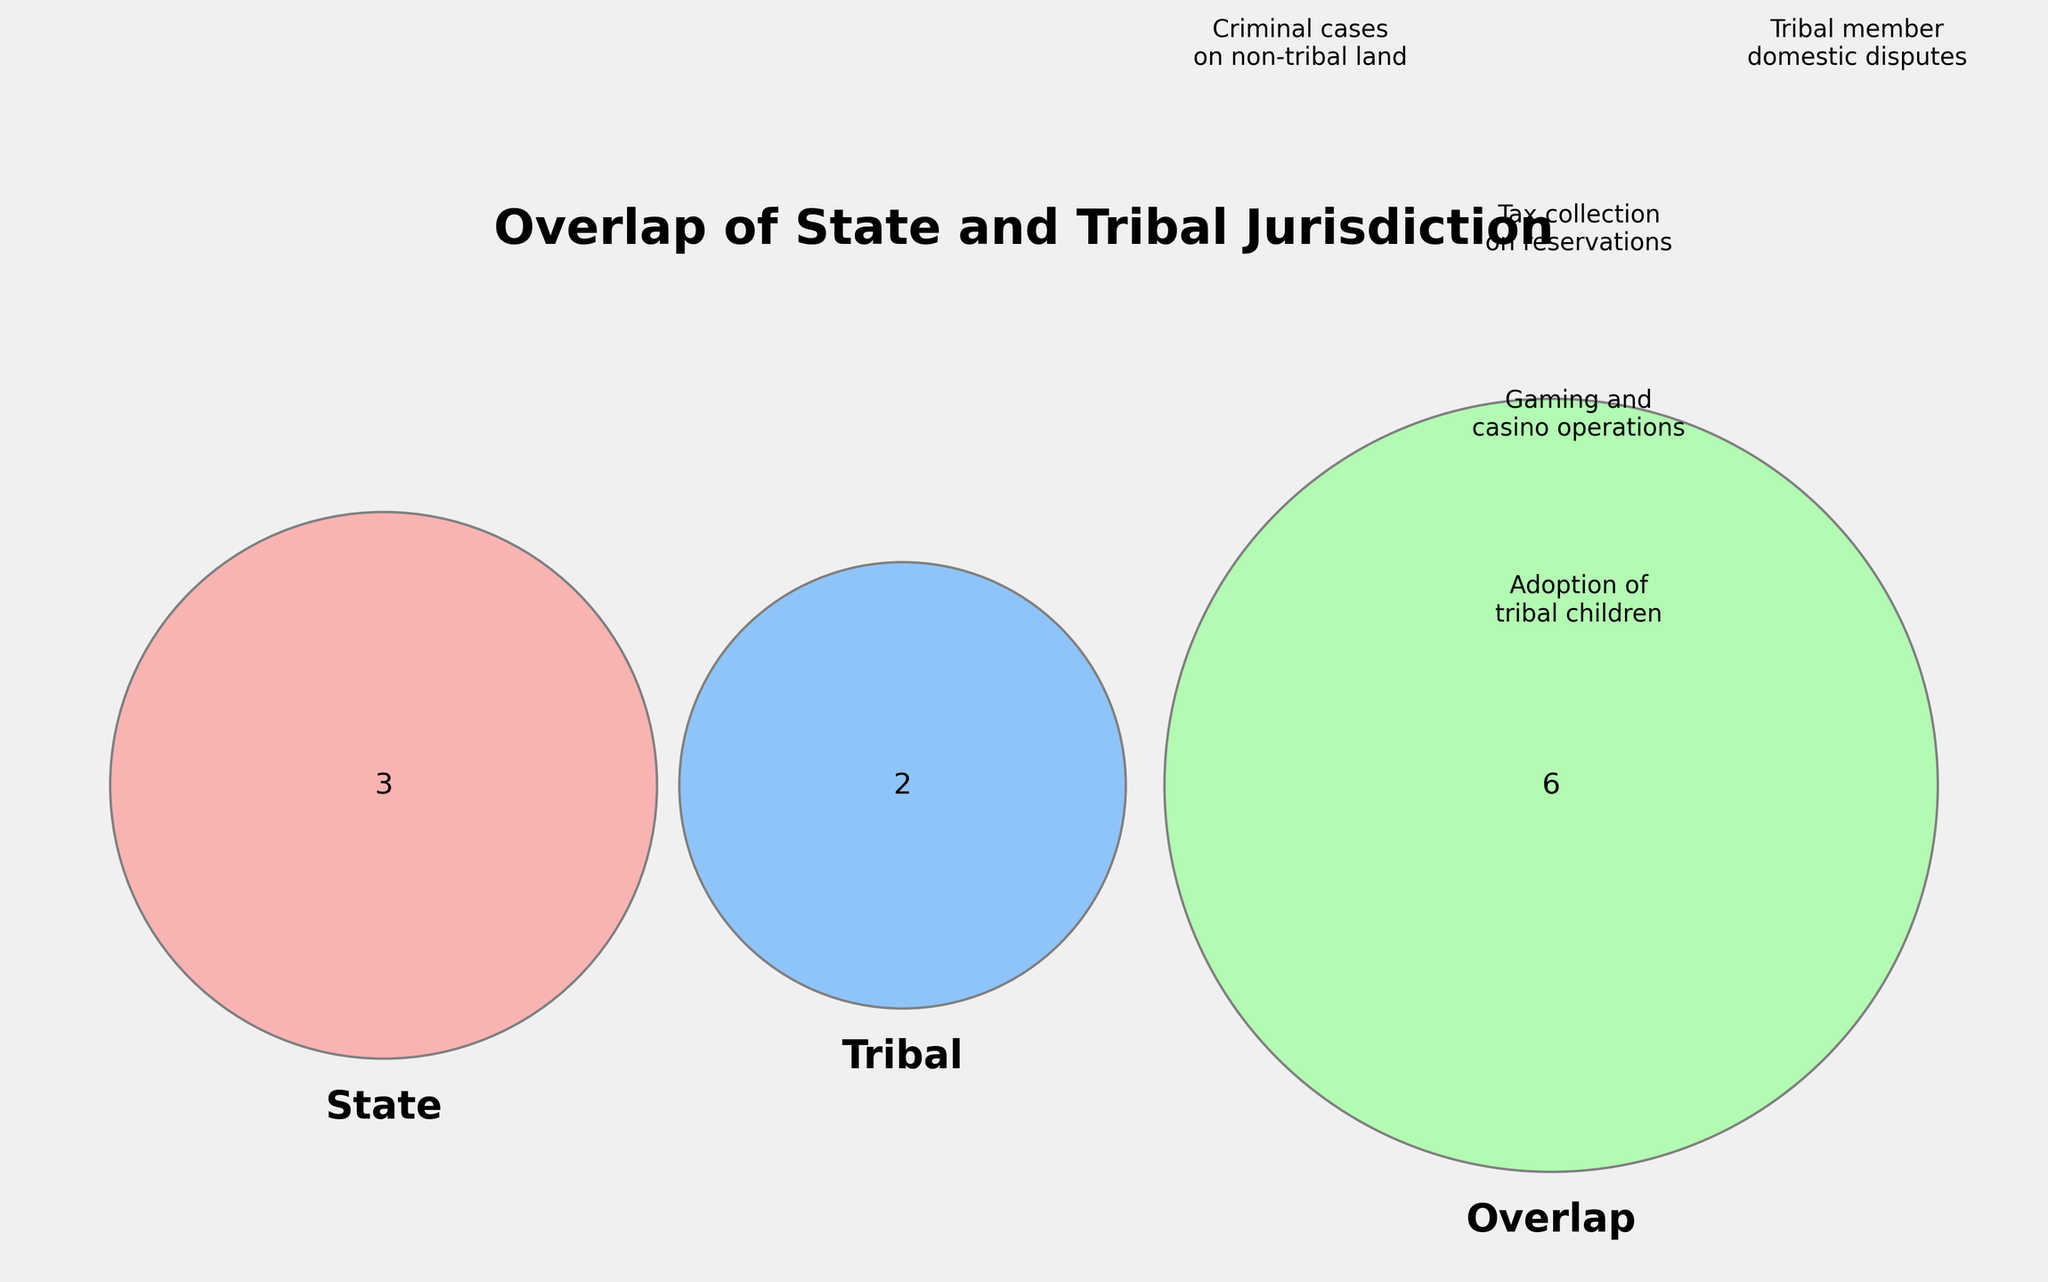What's the title of the figure? The title of the figure is usually placed at the top of the chart in a large and bold font.
Answer: Overlap of State and Tribal Jurisdiction Which categories fall solely under state jurisdiction? In the Venn diagram, categories solely under state jurisdiction are those inside the state circle but outside the overlap and tribal circles.
Answer: Criminal cases on non-tribal land, Civil disputes between non-tribal members, Traffic violations on state highways Which categories fall solely under tribal jurisdiction? Categories solely under tribal jurisdiction are those inside the tribal circle but outside the overlap and state circles.
Answer: Tribal member domestic disputes, Cultural property protection Which categories illustrate an overlap of state and tribal jurisdictions? Categories illustrating an overlap appear in the intersection area of the state and tribal circles but not in the individual only spaces.
Answer: None What are the colors used for each circle in the Venn diagram? The colors of the circles are distinct and typically used to visually separate the categories clearly. The state is usually red-pinkish, tribal is blue, and overlap is green.
Answer: State: Red-pinkish, Tribal: Blue, Overlap: Green How many categories exist in all three jurisdictions: state, tribal, and overlap? Categories that exist in all three jurisdictions appear in the central intersection of all three circles in the Venn diagram.
Answer: 8 Is cultural property protection under state jurisdiction? You can determine if a category is under state jurisdiction by checking if it's inside the state circle.
Answer: No Is gaming and casino operations exclusively under tribal jurisdiction? To determine if a category falls exclusively under tribal jurisdiction, check if it's entirely within the tribal circle and not overlapping with the state circle.
Answer: No Which jurisdiction solely handles tax collection on reservations, based on the diagram? By looking at the category positions, identify which circle contains the category exclusively.
Answer: Tribal According to the diagram, which categories are under the overlap jurisdiction? Categories in the center overlap region belong to the combined jurisdiction of state and tribal according to the Venn diagram.
Answer: Adoption of tribal children, Environmental regulations, Gaming and casino operations, Fishing and hunting rights, Child welfare cases, Tax collection on reservations 